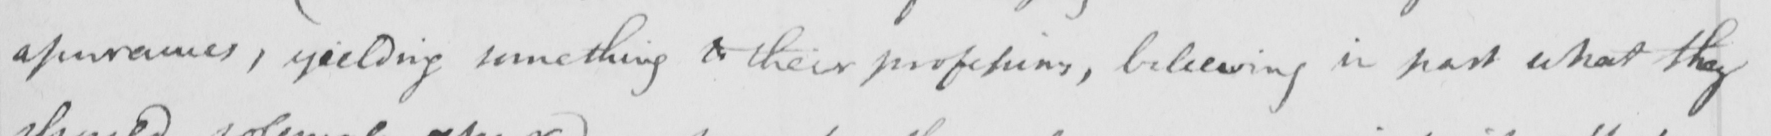Please provide the text content of this handwritten line. apearances , yielding something to their professions , believing in part what they 